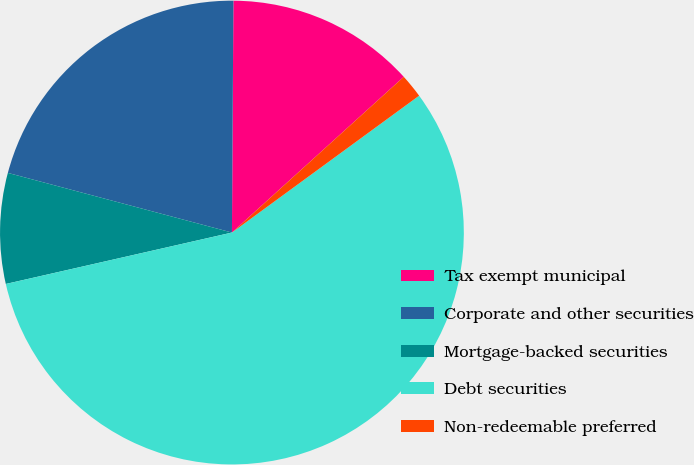Convert chart to OTSL. <chart><loc_0><loc_0><loc_500><loc_500><pie_chart><fcel>Tax exempt municipal<fcel>Corporate and other securities<fcel>Mortgage-backed securities<fcel>Debt securities<fcel>Non-redeemable preferred<nl><fcel>13.18%<fcel>20.96%<fcel>7.7%<fcel>56.49%<fcel>1.67%<nl></chart> 